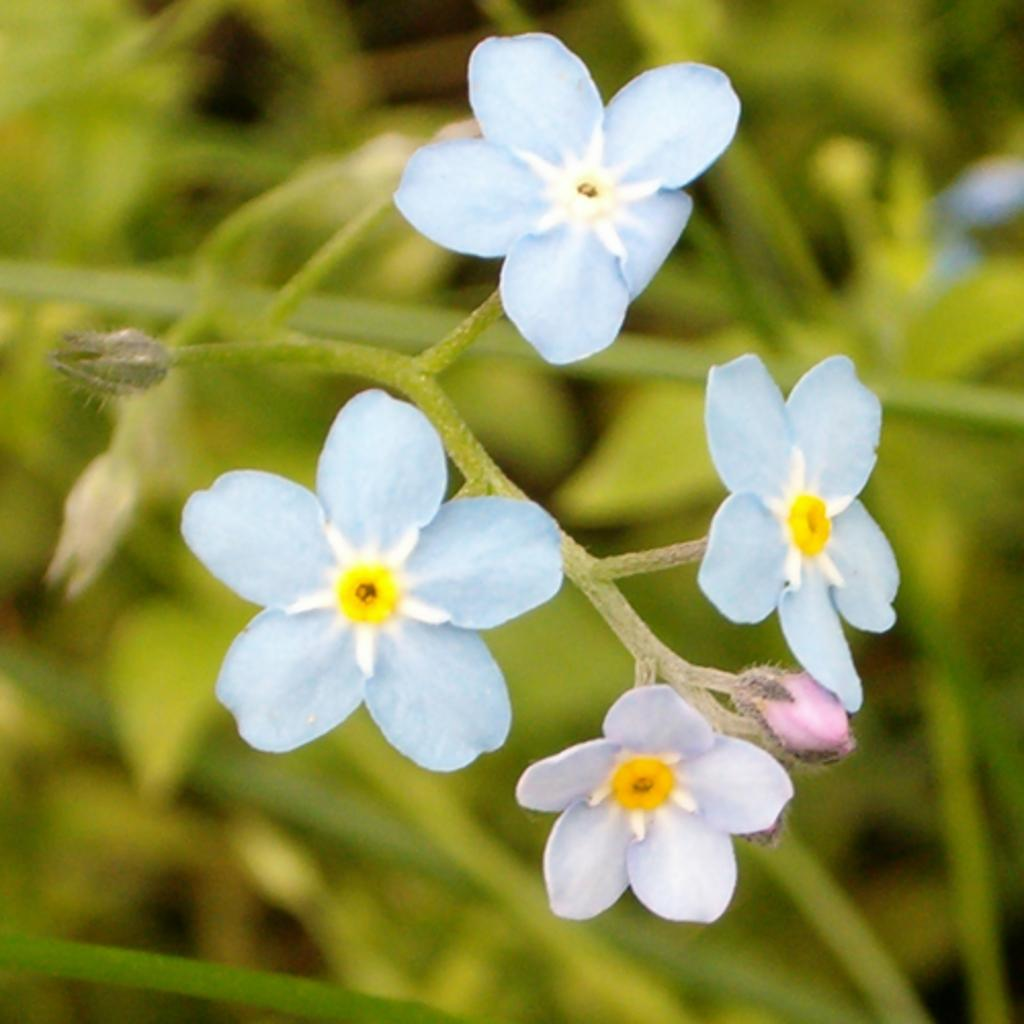What type of living organisms can be seen in the image? There are flowers in the image. What can be seen in the background of the image? There are plants in the background of the image. How many fish can be seen swimming in the image? There are no fish present in the image; it features flowers and plants. What type of finger is visible in the image? There is no finger present in the image. 